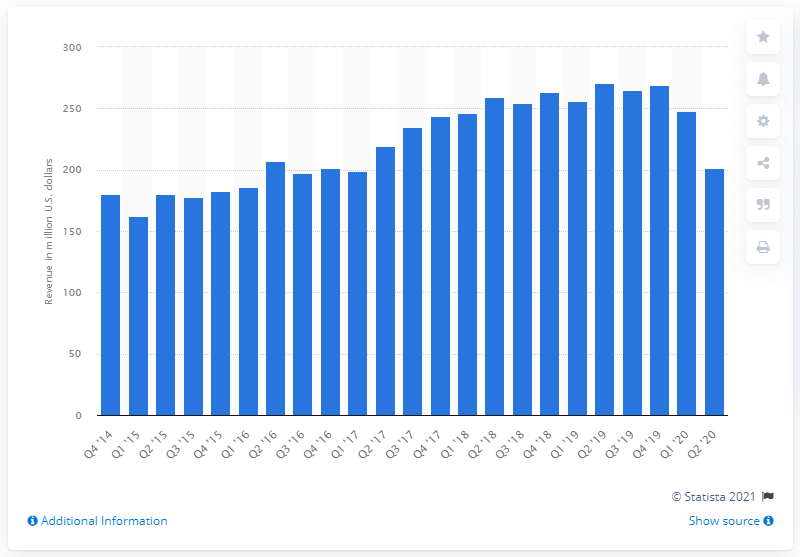Highlight a few significant elements in this photo. eBay's classifieds revenue in the second quarter of 2020 was $.. 